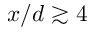<formula> <loc_0><loc_0><loc_500><loc_500>x / d \gtrsim 4</formula> 